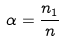Convert formula to latex. <formula><loc_0><loc_0><loc_500><loc_500>\alpha = \frac { n _ { 1 } } { n }</formula> 